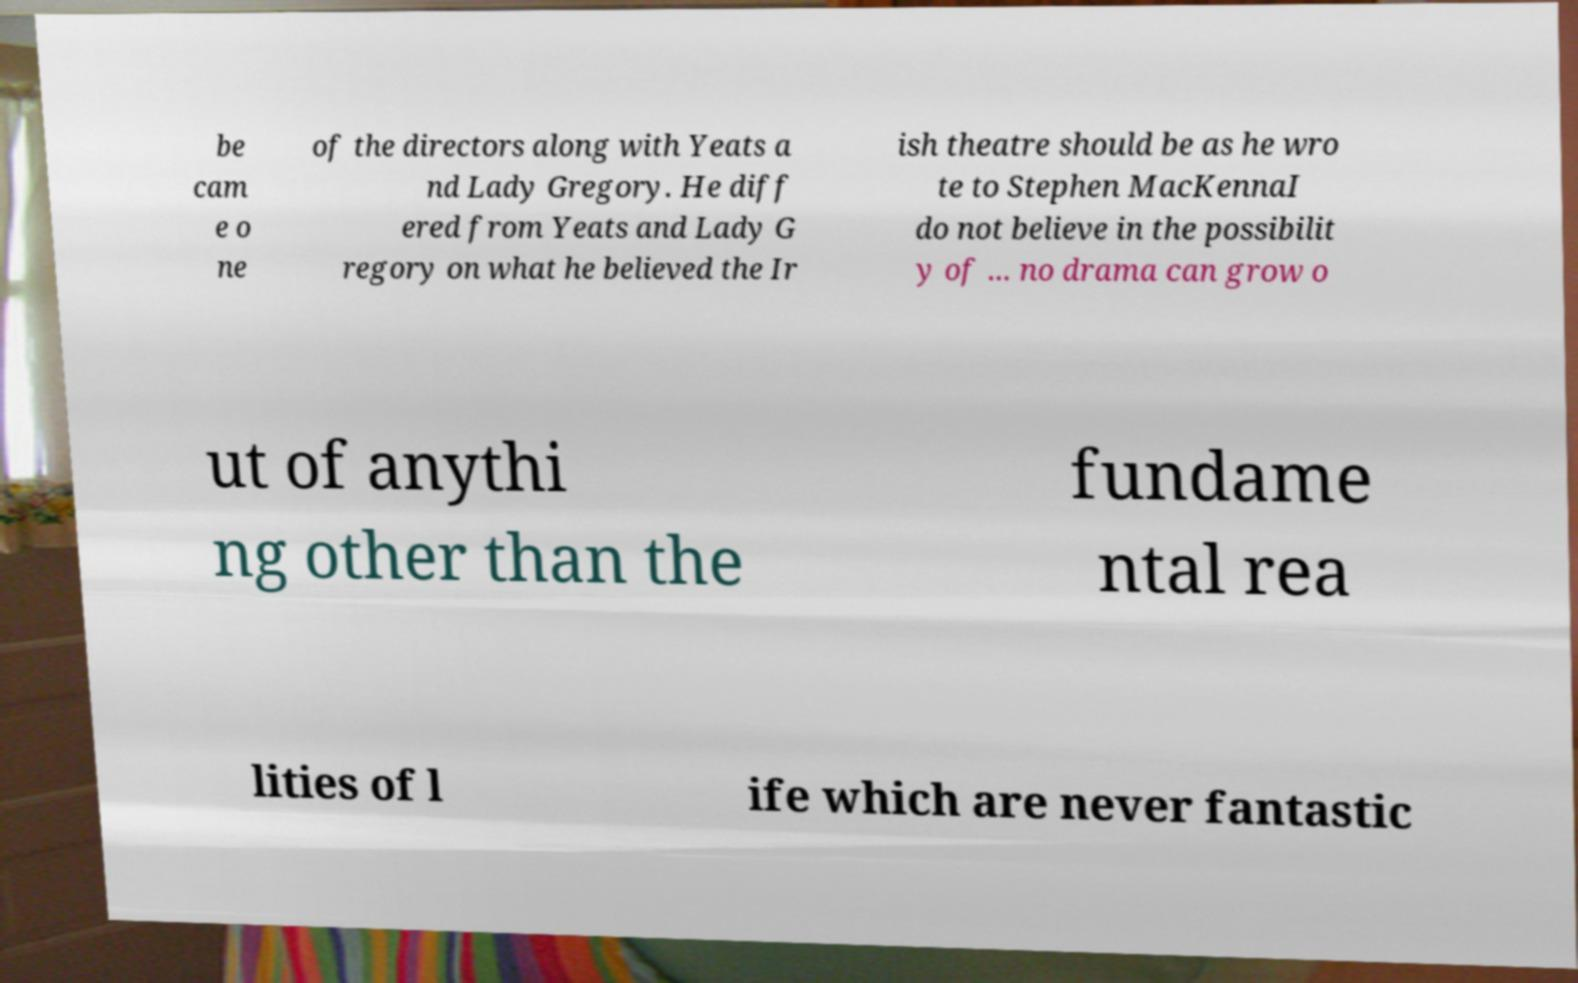Can you accurately transcribe the text from the provided image for me? be cam e o ne of the directors along with Yeats a nd Lady Gregory. He diff ered from Yeats and Lady G regory on what he believed the Ir ish theatre should be as he wro te to Stephen MacKennaI do not believe in the possibilit y of ... no drama can grow o ut of anythi ng other than the fundame ntal rea lities of l ife which are never fantastic 